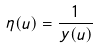Convert formula to latex. <formula><loc_0><loc_0><loc_500><loc_500>\eta ( u ) = \frac { 1 } { y ( u ) }</formula> 